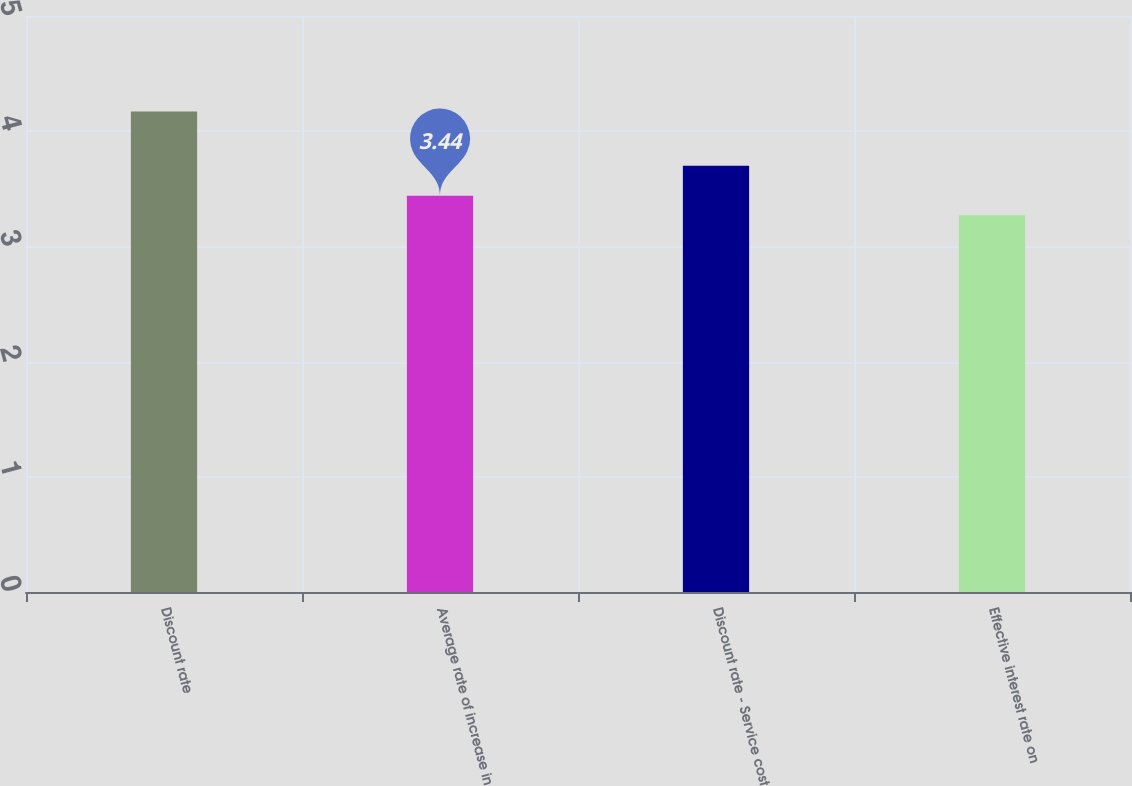<chart> <loc_0><loc_0><loc_500><loc_500><bar_chart><fcel>Discount rate<fcel>Average rate of increase in<fcel>Discount rate - Service cost<fcel>Effective interest rate on<nl><fcel>4.17<fcel>3.44<fcel>3.7<fcel>3.27<nl></chart> 